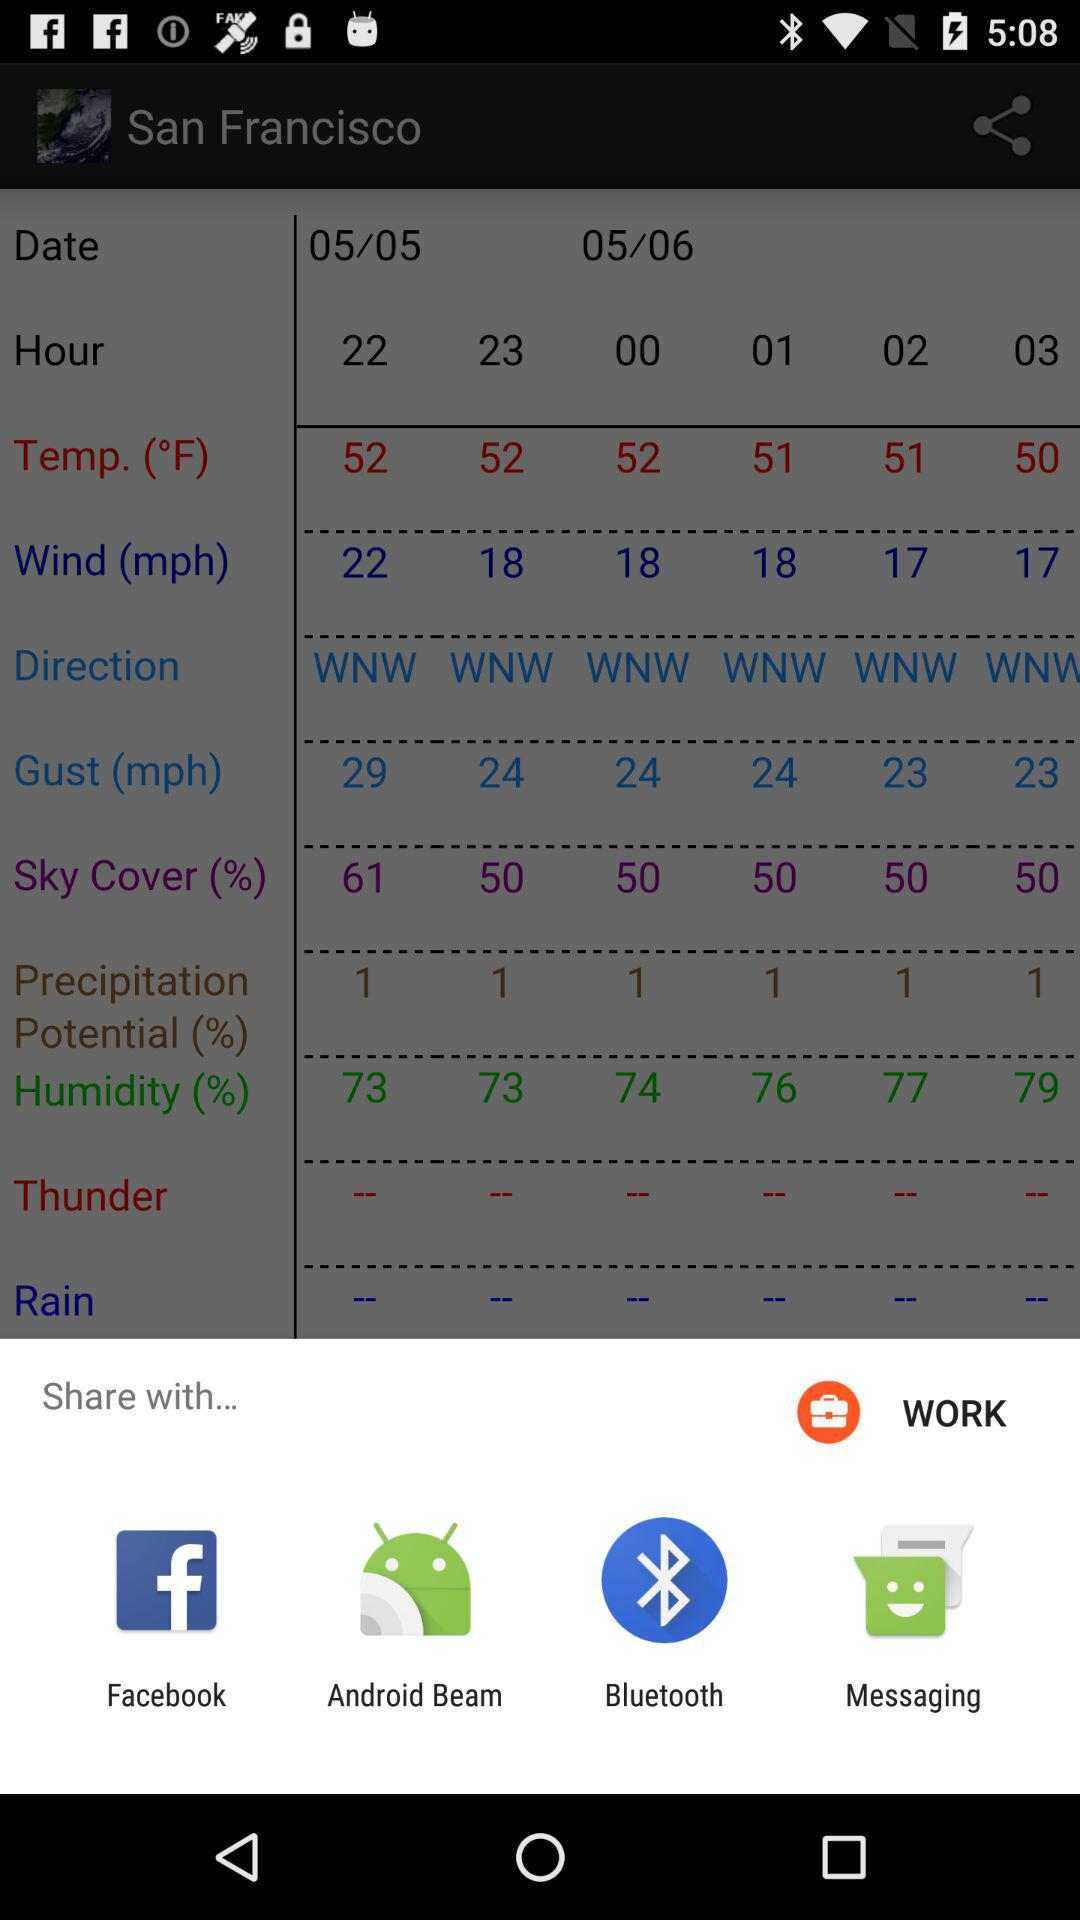What sharing options are given? The sharing options are "Facebook", "Android Beam", "Bluetooth" and "Messaging". 